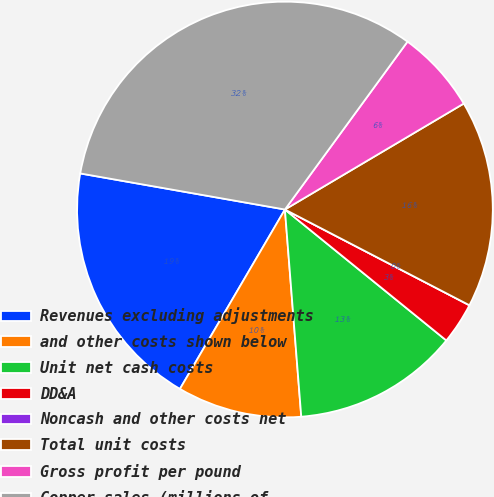Convert chart to OTSL. <chart><loc_0><loc_0><loc_500><loc_500><pie_chart><fcel>Revenues excluding adjustments<fcel>and other costs shown below<fcel>Unit net cash costs<fcel>DD&A<fcel>Noncash and other costs net<fcel>Total unit costs<fcel>Gross profit per pound<fcel>Copper sales (millions of<nl><fcel>19.35%<fcel>9.68%<fcel>12.9%<fcel>3.23%<fcel>0.0%<fcel>16.13%<fcel>6.45%<fcel>32.26%<nl></chart> 